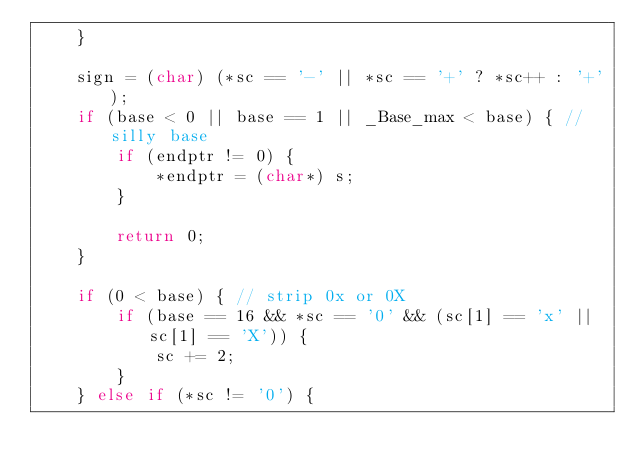Convert code to text. <code><loc_0><loc_0><loc_500><loc_500><_C++_>    }

    sign = (char) (*sc == '-' || *sc == '+' ? *sc++ : '+');
    if (base < 0 || base == 1 || _Base_max < base) { // silly base
        if (endptr != 0) {
            *endptr = (char*) s;
        }

        return 0;
    }

    if (0 < base) { // strip 0x or 0X
        if (base == 16 && *sc == '0' && (sc[1] == 'x' || sc[1] == 'X')) {
            sc += 2;
        }
    } else if (*sc != '0') {</code> 